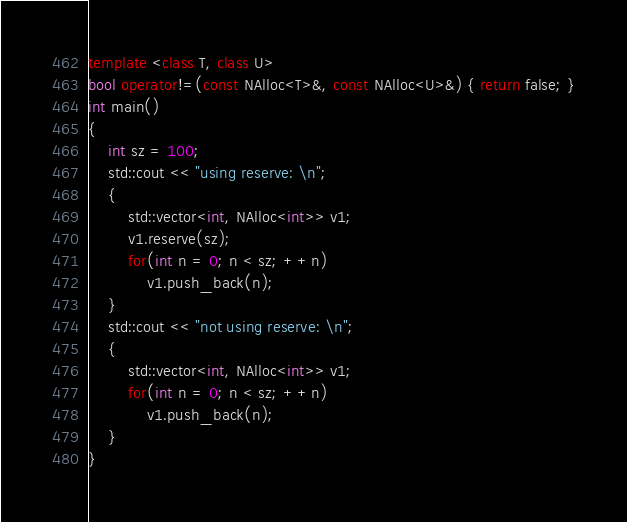Convert code to text. <code><loc_0><loc_0><loc_500><loc_500><_C++_>template <class T, class U>
bool operator!=(const NAlloc<T>&, const NAlloc<U>&) { return false; }
int main()
{
    int sz = 100;
    std::cout << "using reserve: \n";
    {
        std::vector<int, NAlloc<int>> v1;
        v1.reserve(sz);
        for(int n = 0; n < sz; ++n)
            v1.push_back(n);
    }
    std::cout << "not using reserve: \n";
    {
        std::vector<int, NAlloc<int>> v1;
        for(int n = 0; n < sz; ++n)
            v1.push_back(n);
    }
}

</code> 